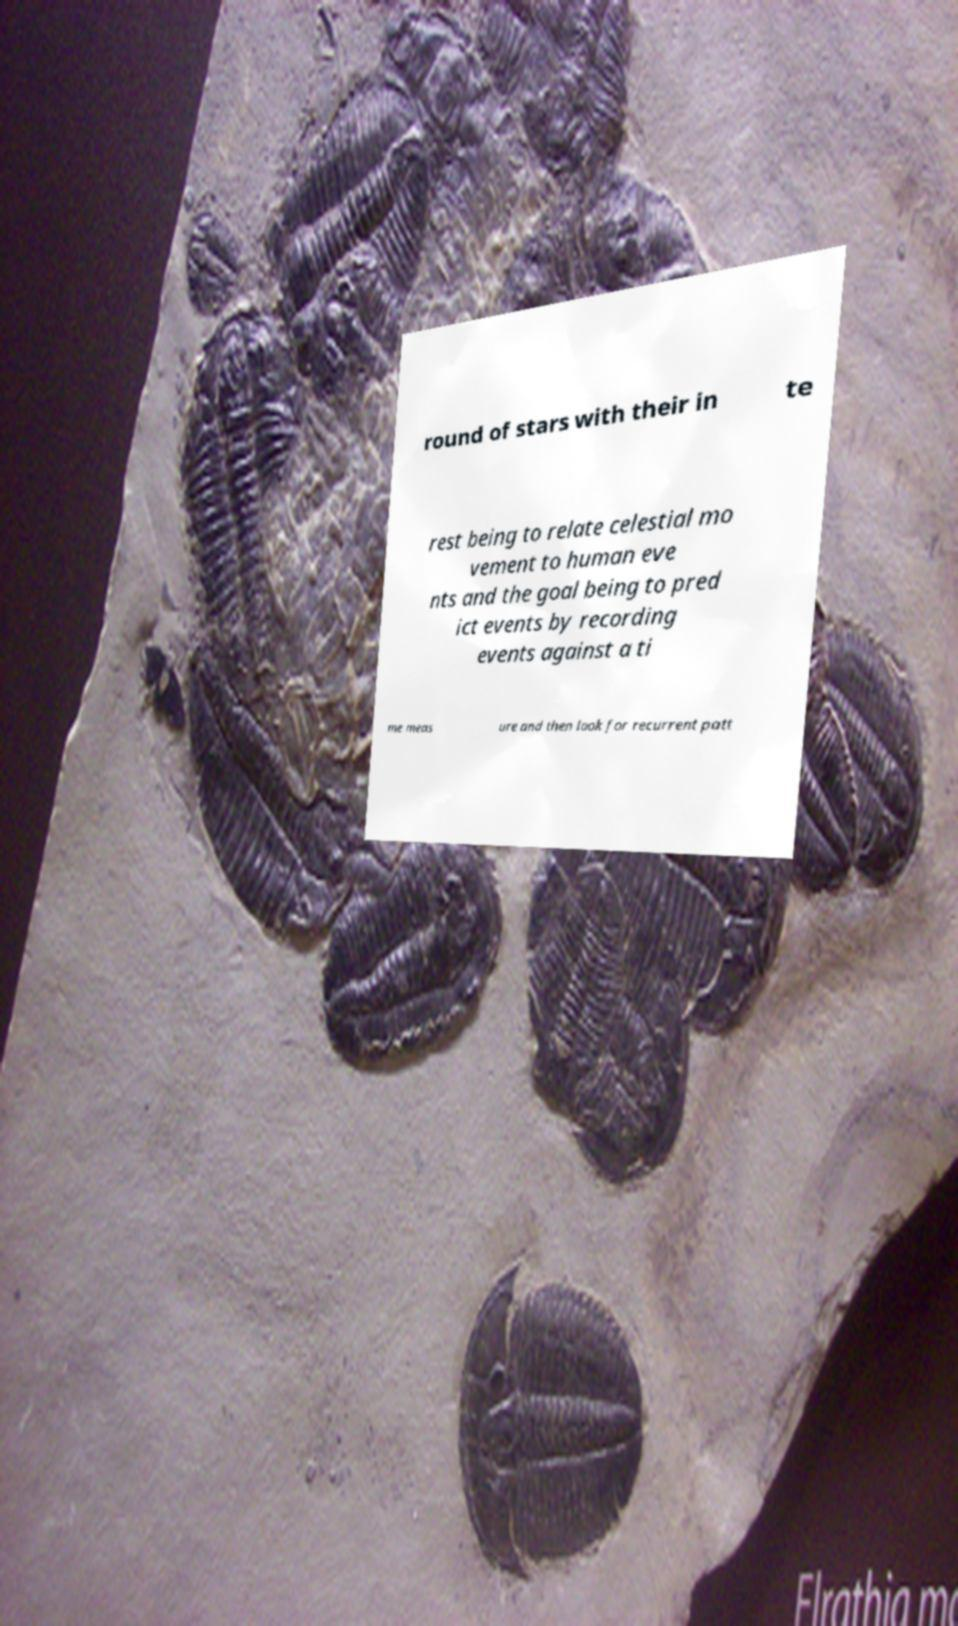I need the written content from this picture converted into text. Can you do that? round of stars with their in te rest being to relate celestial mo vement to human eve nts and the goal being to pred ict events by recording events against a ti me meas ure and then look for recurrent patt 